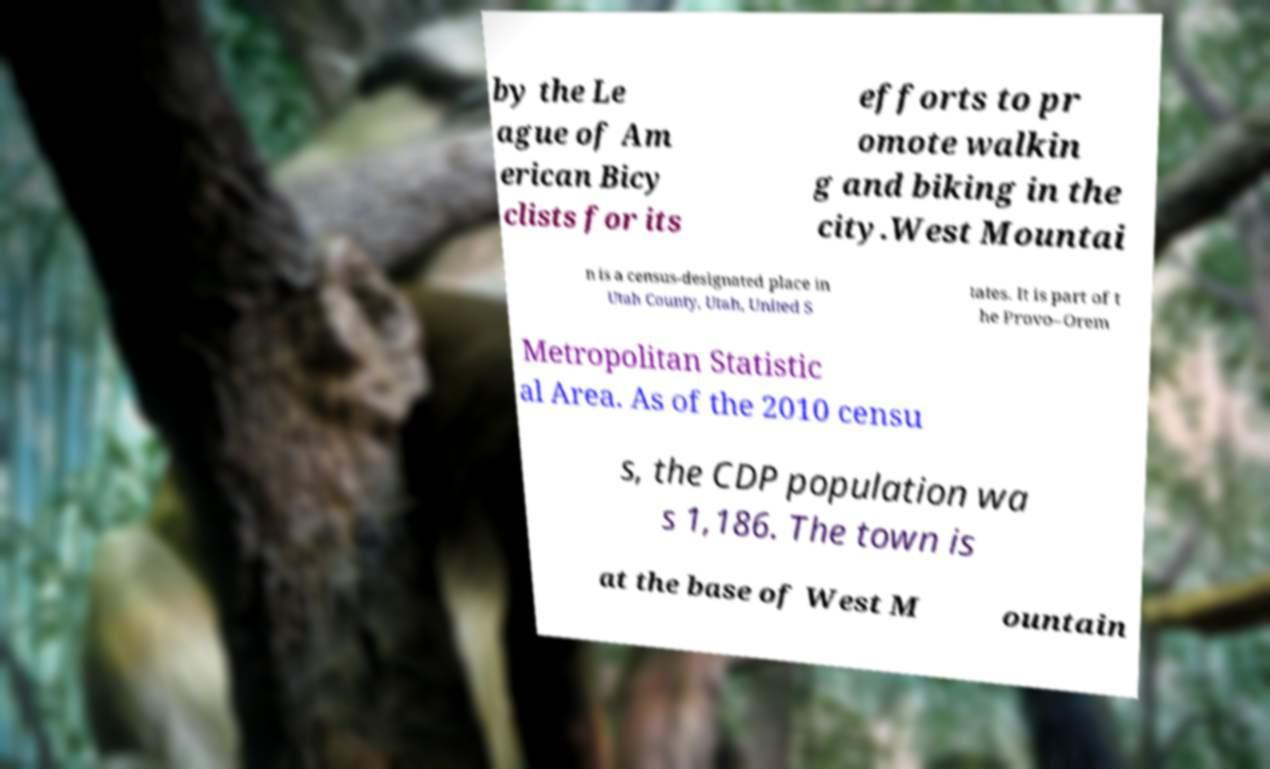For documentation purposes, I need the text within this image transcribed. Could you provide that? by the Le ague of Am erican Bicy clists for its efforts to pr omote walkin g and biking in the city.West Mountai n is a census-designated place in Utah County, Utah, United S tates. It is part of t he Provo–Orem Metropolitan Statistic al Area. As of the 2010 censu s, the CDP population wa s 1,186. The town is at the base of West M ountain 